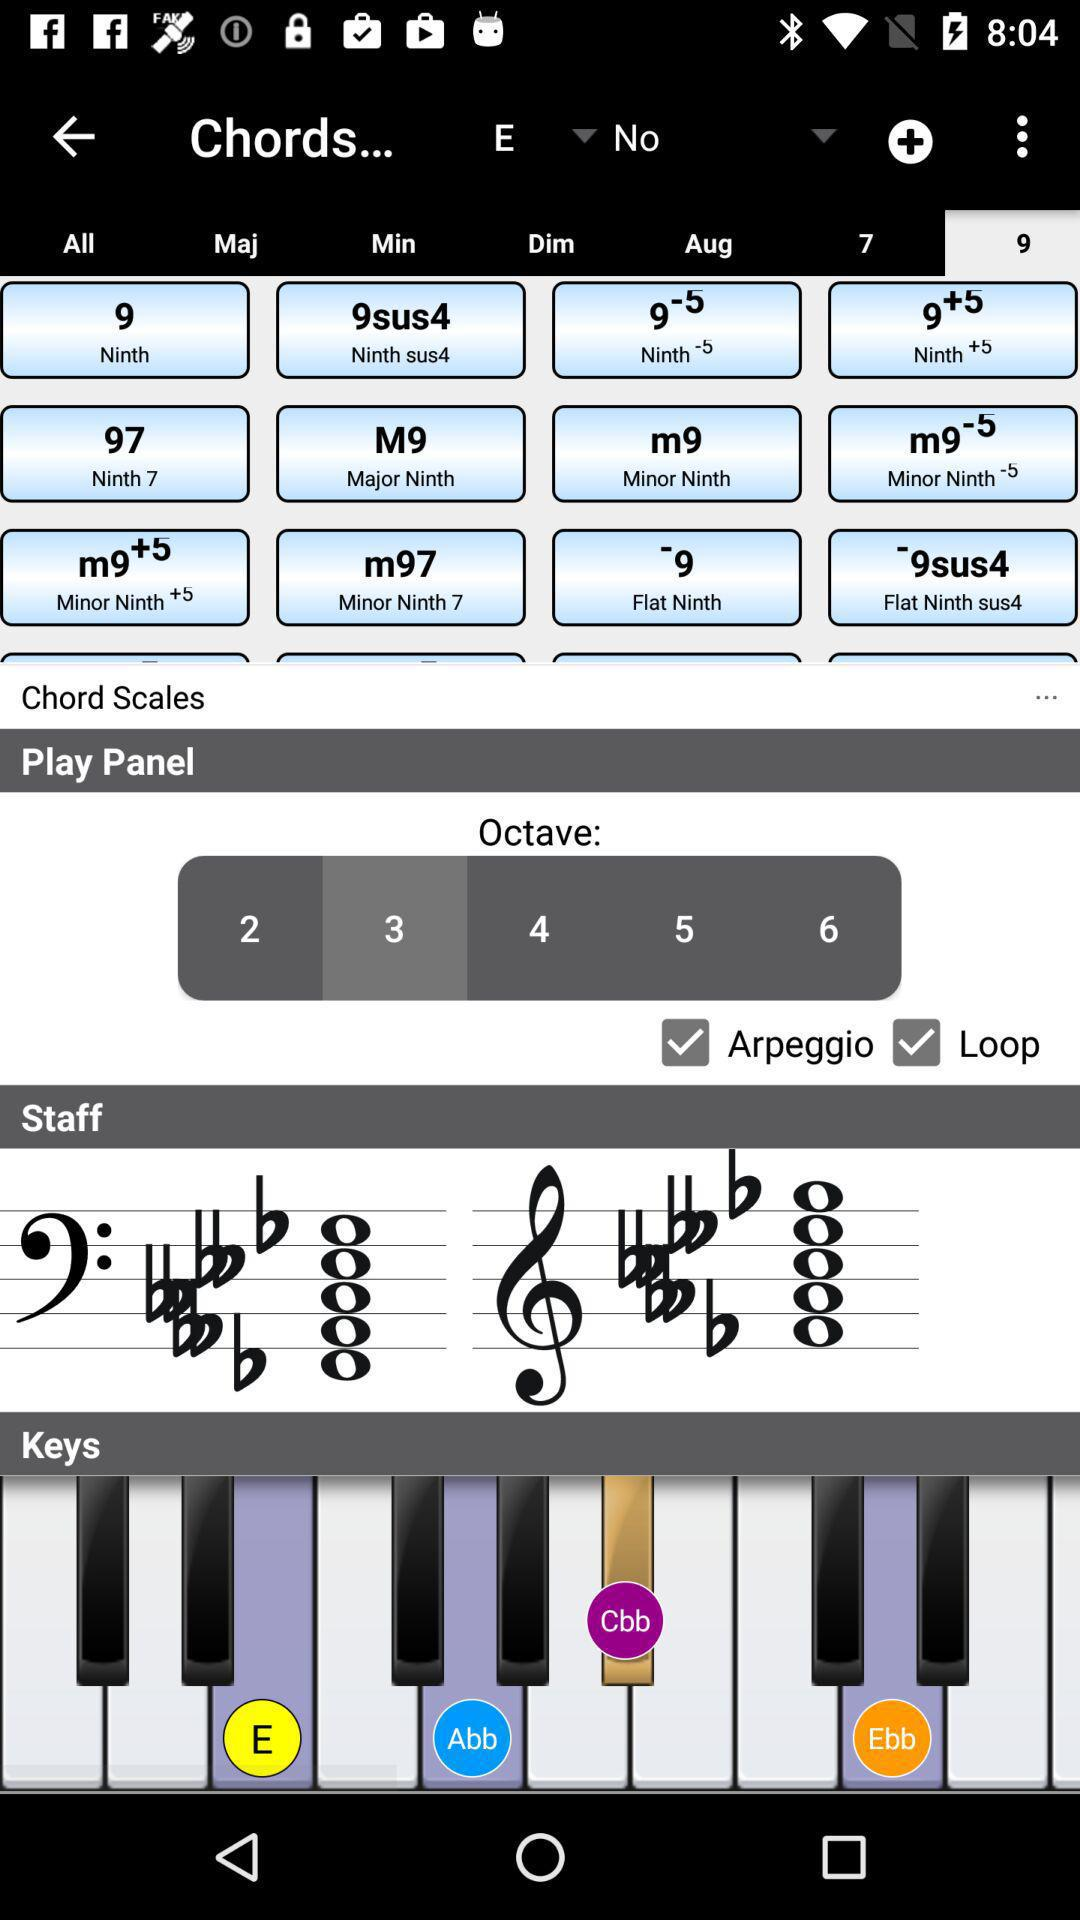What is the status of "Chord Scales"?
When the provided information is insufficient, respond with <no answer>. <no answer> 